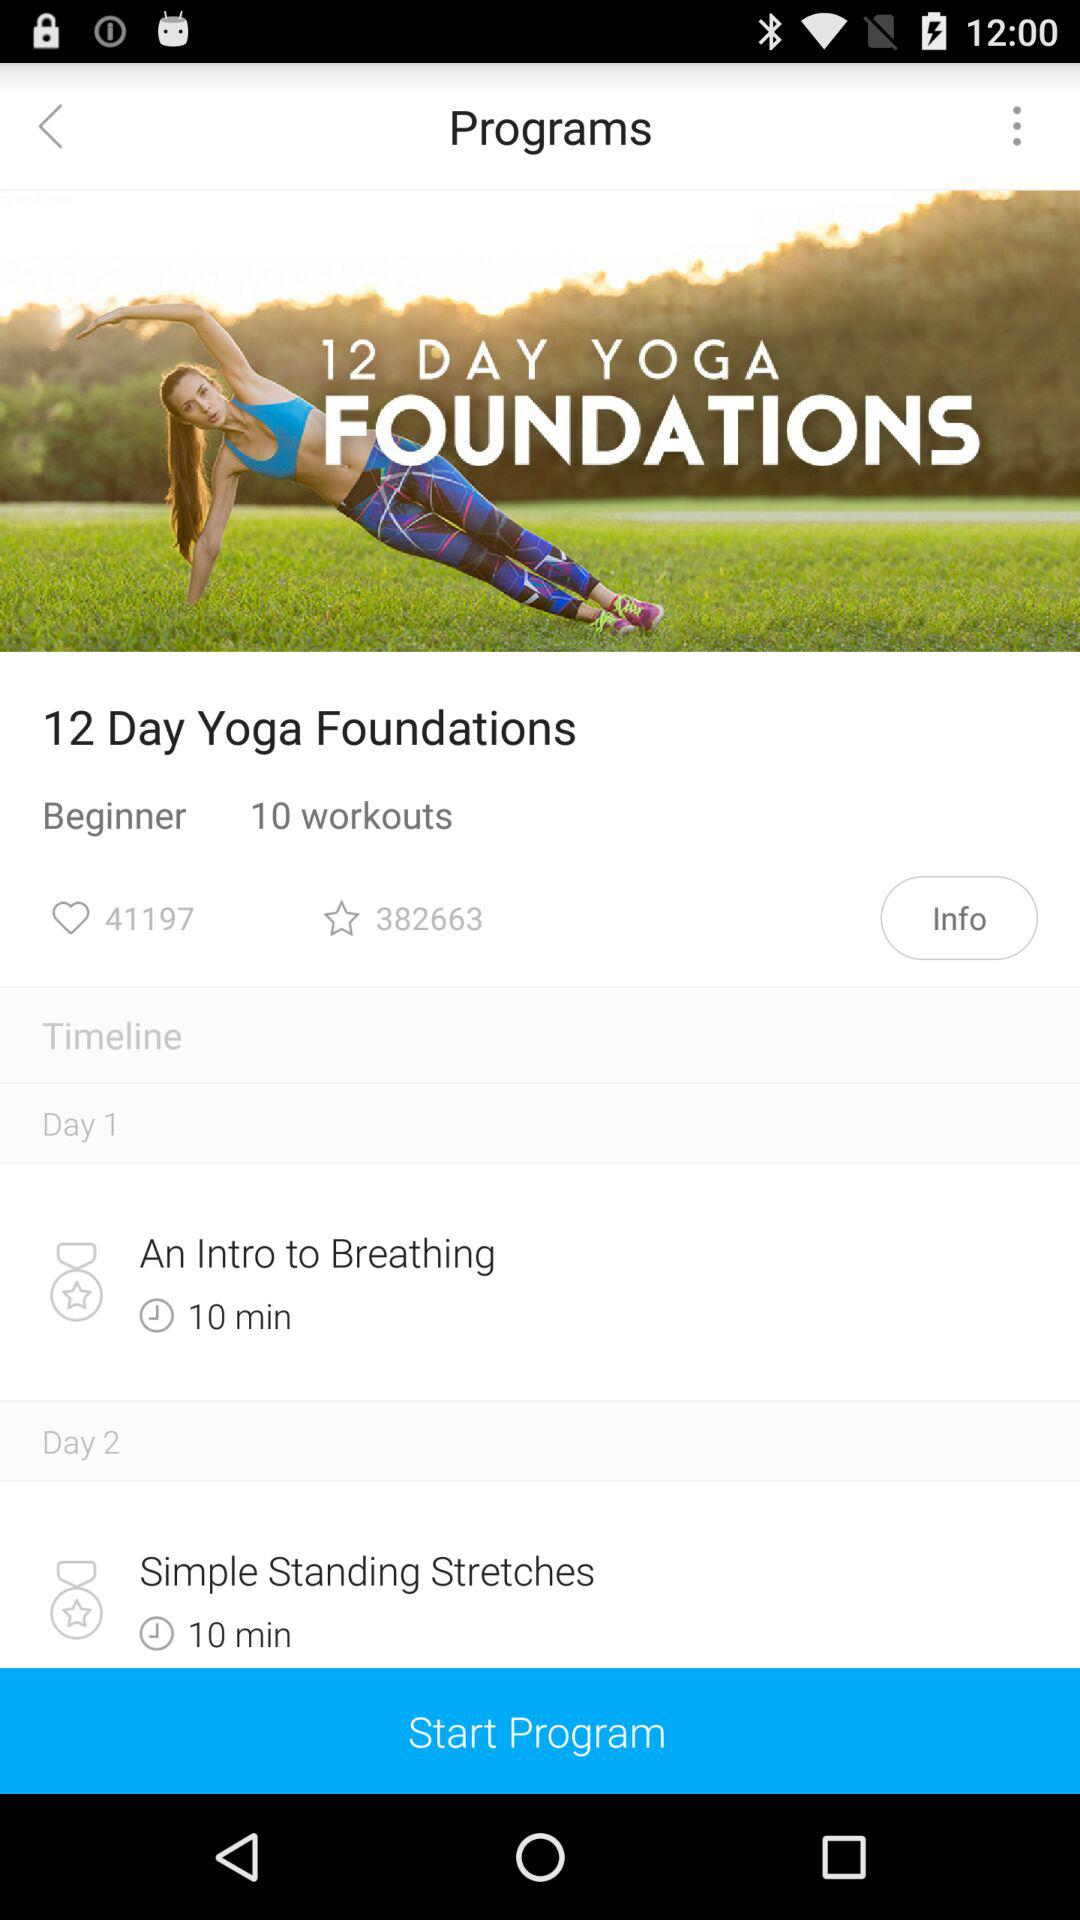What is the schedule for Day 1? The schedule for Day 1 is "An Intro to Breathing". 